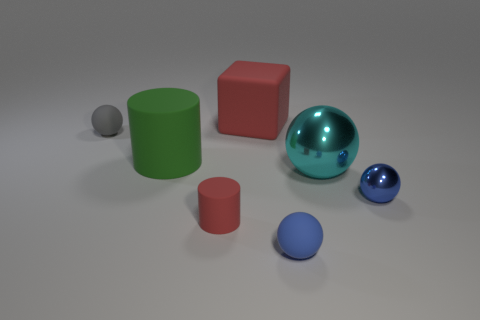The tiny blue object that is the same material as the tiny gray thing is what shape?
Your answer should be very brief. Sphere. What number of big objects are left of the big ball and to the right of the big red cube?
Provide a succinct answer. 0. Are there any blue matte spheres left of the small red object?
Your answer should be very brief. No. Is the shape of the shiny object on the left side of the tiny blue shiny ball the same as the red matte object that is in front of the tiny gray matte thing?
Ensure brevity in your answer.  No. How many objects are either small objects or small objects left of the small red object?
Keep it short and to the point. 4. How many other things are the same shape as the blue metal thing?
Your answer should be very brief. 3. Does the ball that is left of the big red object have the same material as the red cylinder?
Keep it short and to the point. Yes. How many objects are cyan metal balls or green things?
Make the answer very short. 2. The gray matte object that is the same shape as the blue matte thing is what size?
Make the answer very short. Small. The green cylinder is what size?
Make the answer very short. Large. 